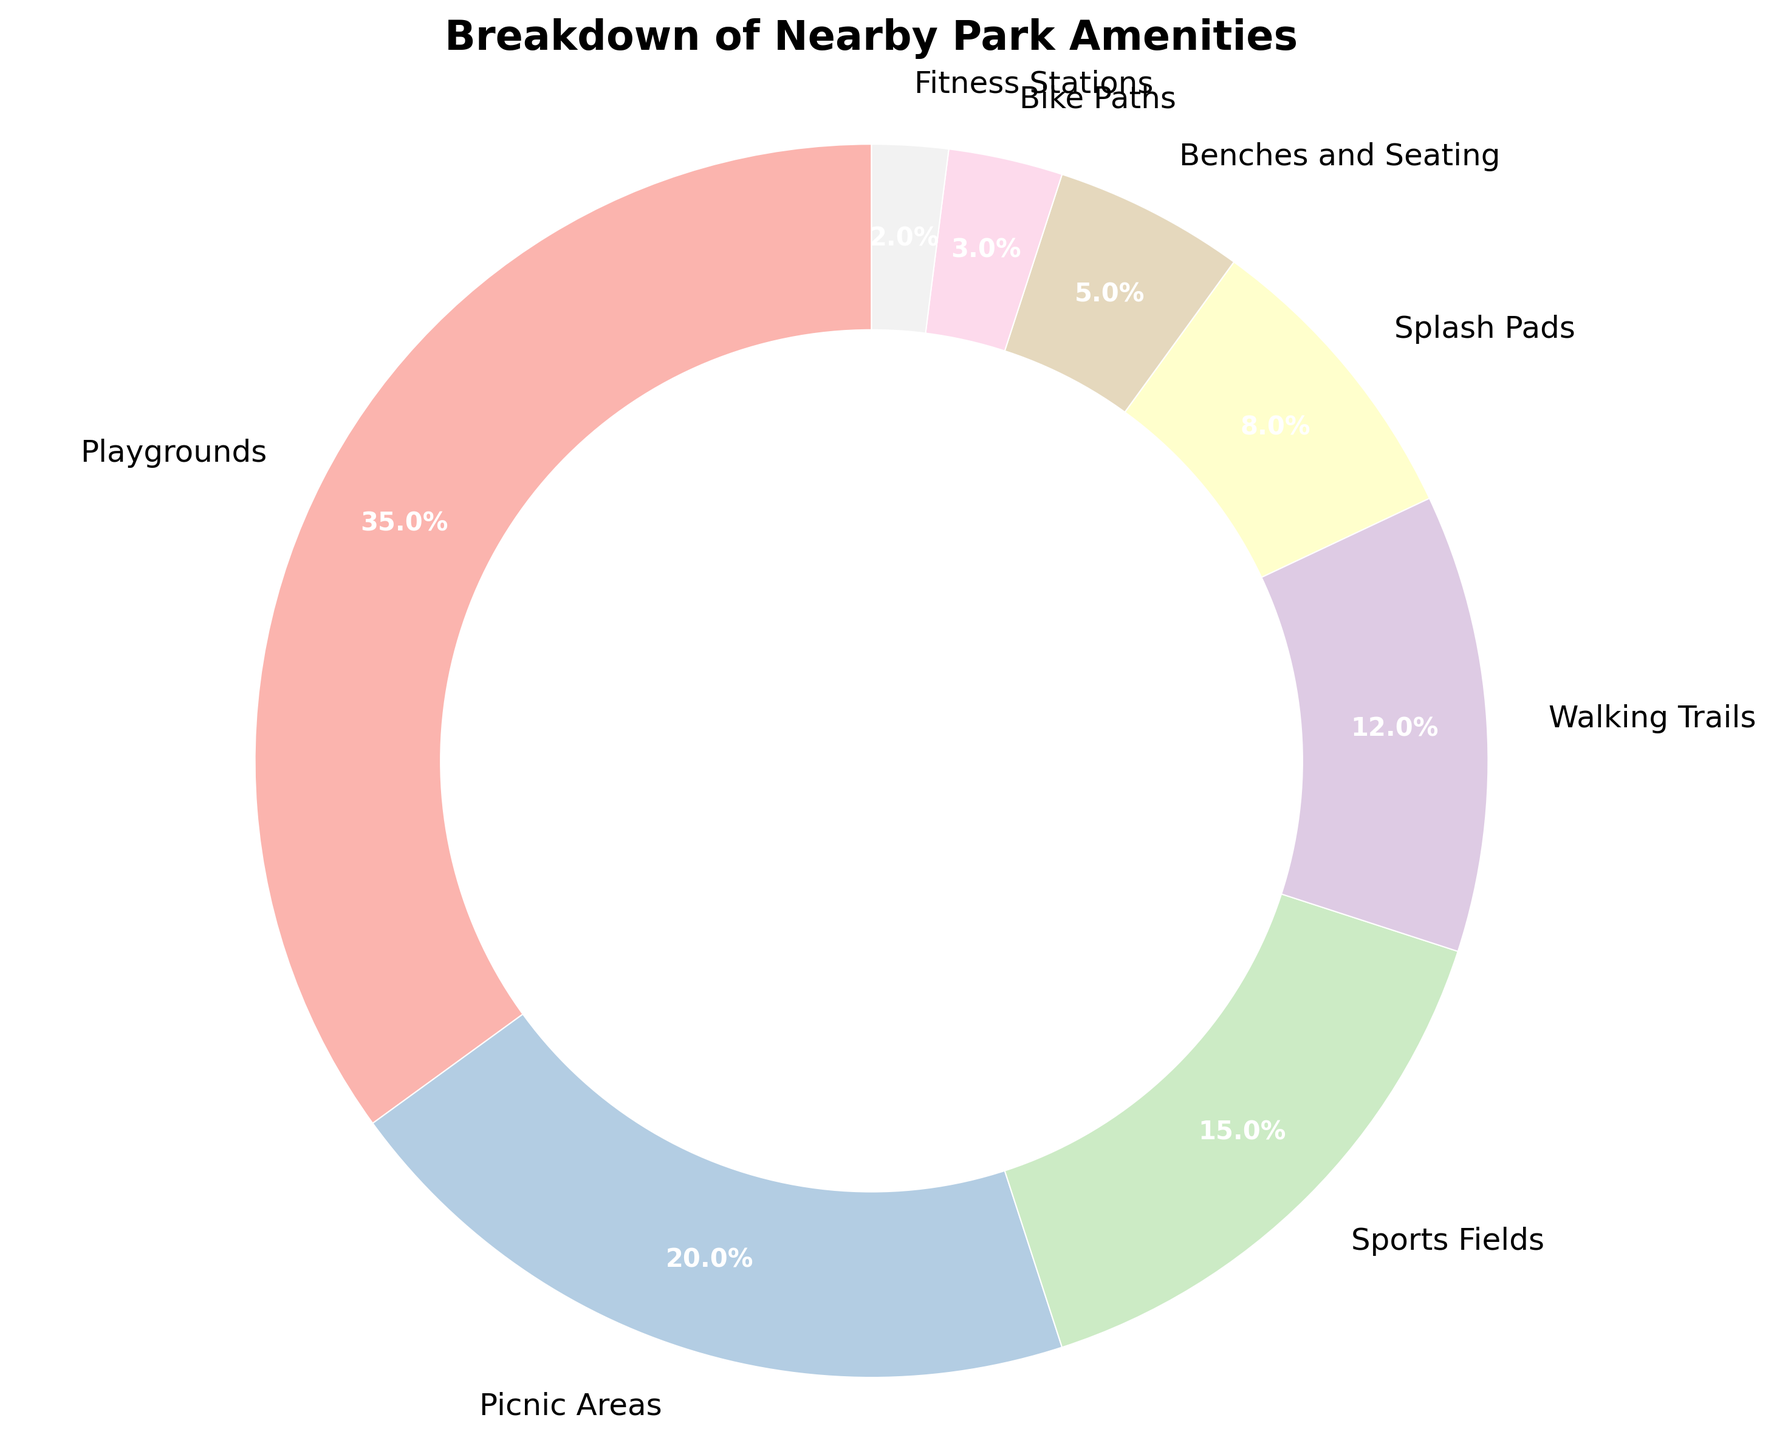What's the largest amenity by percentage? Looking at the pie chart, the largest wedge corresponds to the 'Playgrounds' section.
Answer: Playgrounds Which amenity has the smallest percentage? The smallest wedge on the pie chart is for 'Fitness Stations'.
Answer: Fitness Stations What is the combined percentage of Picnic Areas, Splash Pads, and Benches and Seating? The percentages for Picnic Areas, Splash Pads, and Benches and Seating are 20%, 8%, and 5% respectively. Summing these up: 20 + 8 + 5 = 33%.
Answer: 33% How much more percentage do Playgrounds have compared to Sports Fields? Playgrounds have a percentage of 35% and Sports Fields have 15%. The difference is 35 - 15 = 20%.
Answer: 20% Which amenities contribute more than 10% each to the total? The amenities contributing more than 10% each are Playgrounds (35%), Picnic Areas (20%), and Sports Fields (15%).
Answer: Playgrounds, Picnic Areas, Sports Fields What is the fourth largest amenity by percentage? Based on the size of the wedges in descending order, the fourth largest is Walking Trails at 12%.
Answer: Walking Trails Do Splash Pads and Fitness Stations together make up more or less than 10% of the total? Splash Pads have 8% and Fitness Stations have 2%. Adding these together: 8 + 2 = 10%. They make up exactly 10% of the total.
Answer: Equal to 10% How many amenities contribute less than 5% each? The amenities contributing less than 5% each are Bike Paths (3%) and Fitness Stations (2%). That's a total of 2 amenities.
Answer: 2 What is the percentage difference between Walking Trails and Bike Paths? Walking Trails have 12% and Bike Paths have 3%. The difference is 12 - 3 = 9%.
Answer: 9% 